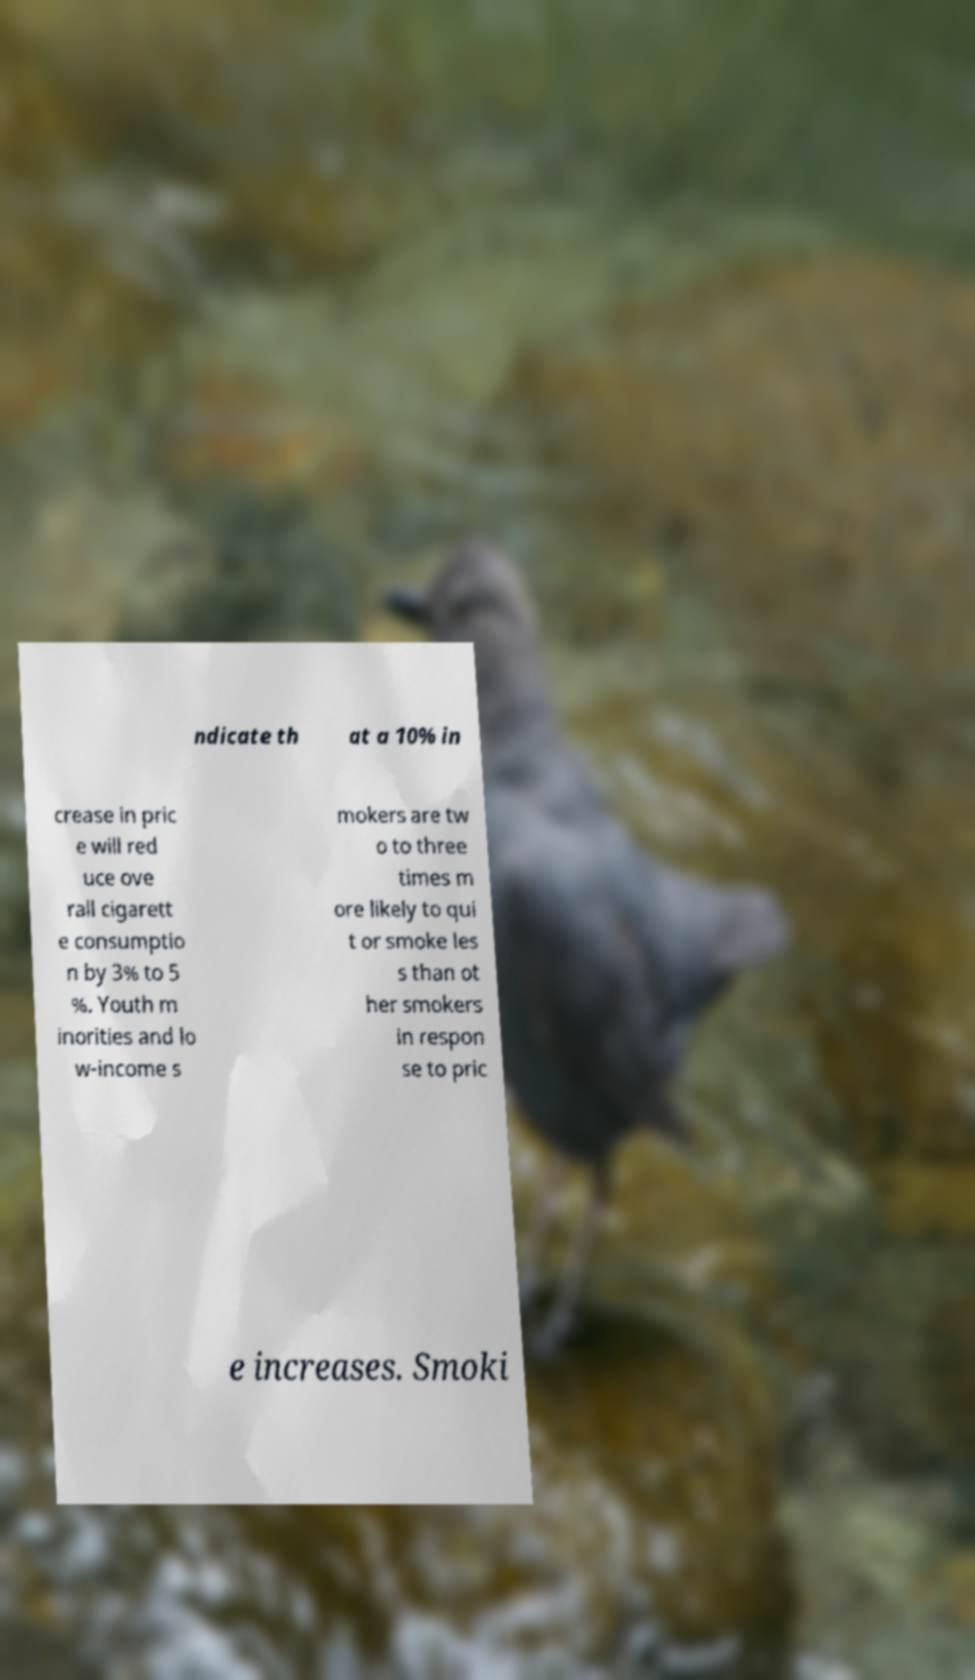What messages or text are displayed in this image? I need them in a readable, typed format. ndicate th at a 10% in crease in pric e will red uce ove rall cigarett e consumptio n by 3% to 5 %. Youth m inorities and lo w-income s mokers are tw o to three times m ore likely to qui t or smoke les s than ot her smokers in respon se to pric e increases. Smoki 